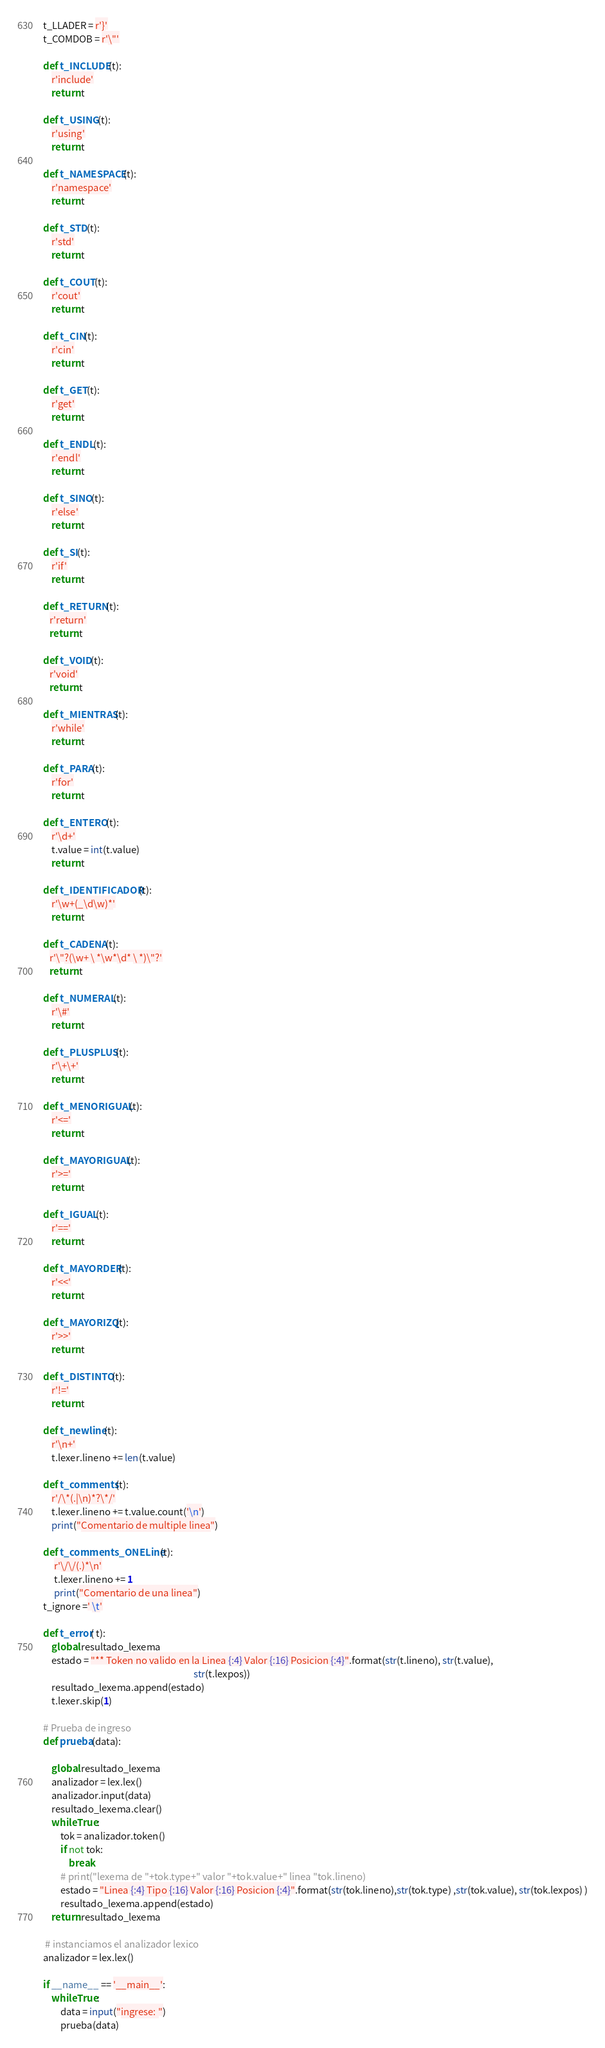Convert code to text. <code><loc_0><loc_0><loc_500><loc_500><_Python_>t_LLADER = r'}'
t_COMDOB = r'\"'

def t_INCLUDE(t):
    r'include'
    return t

def t_USING(t):
    r'using'
    return t

def t_NAMESPACE(t):
    r'namespace'
    return t

def t_STD(t):
    r'std'
    return t

def t_COUT(t):
    r'cout'
    return t

def t_CIN(t):
    r'cin'
    return t

def t_GET(t):
    r'get'
    return t

def t_ENDL(t):
    r'endl'
    return t

def t_SINO(t):
    r'else'
    return t

def t_SI(t):
    r'if'
    return t

def t_RETURN(t):
   r'return'
   return t

def t_VOID(t):
   r'void'
   return t

def t_MIENTRAS(t):
    r'while'
    return t

def t_PARA(t):
    r'for'
    return t

def t_ENTERO(t):
    r'\d+'
    t.value = int(t.value)
    return t

def t_IDENTIFICADOR(t):
    r'\w+(_\d\w)*'
    return t

def t_CADENA(t):
   r'\"?(\w+ \ *\w*\d* \ *)\"?'
   return t

def t_NUMERAL(t):
    r'\#'
    return t

def t_PLUSPLUS(t):
    r'\+\+'
    return t

def t_MENORIGUAL(t):
    r'<='
    return t

def t_MAYORIGUAL(t):
    r'>='
    return t

def t_IGUAL(t):
    r'=='
    return t

def t_MAYORDER(t):
    r'<<'
    return t

def t_MAYORIZQ(t):
    r'>>'
    return t

def t_DISTINTO(t):
    r'!='
    return t

def t_newline(t):
    r'\n+'
    t.lexer.lineno += len(t.value)

def t_comments(t):
    r'/\*(.|\n)*?\*/'
    t.lexer.lineno += t.value.count('\n')
    print("Comentario de multiple linea")

def t_comments_ONELine(t):
     r'\/\/(.)*\n'
     t.lexer.lineno += 1
     print("Comentario de una linea")
t_ignore =' \t'

def t_error( t):
    global resultado_lexema
    estado = "** Token no valido en la Linea {:4} Valor {:16} Posicion {:4}".format(str(t.lineno), str(t.value),
                                                                      str(t.lexpos))
    resultado_lexema.append(estado)
    t.lexer.skip(1)

# Prueba de ingreso
def prueba(data):

    global resultado_lexema
    analizador = lex.lex()
    analizador.input(data)
    resultado_lexema.clear()
    while True:
        tok = analizador.token()
        if not tok:
            break
        # print("lexema de "+tok.type+" valor "+tok.value+" linea "tok.lineno)
        estado = "Linea {:4} Tipo {:16} Valor {:16} Posicion {:4}".format(str(tok.lineno),str(tok.type) ,str(tok.value), str(tok.lexpos) )
        resultado_lexema.append(estado)
    return resultado_lexema

 # instanciamos el analizador lexico
analizador = lex.lex()

if __name__ == '__main__':
    while True:
        data = input("ingrese: ")
        prueba(data)
</code> 